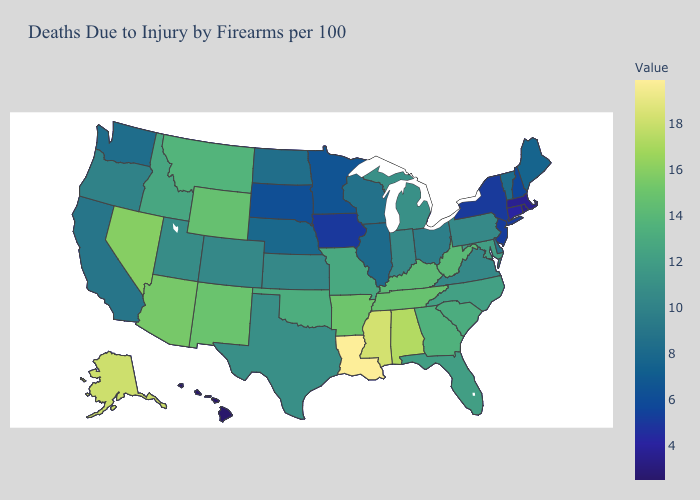Does Wisconsin have the lowest value in the MidWest?
Answer briefly. No. Among the states that border Alabama , does Mississippi have the highest value?
Keep it brief. Yes. Does Alabama have a higher value than Tennessee?
Answer briefly. Yes. 